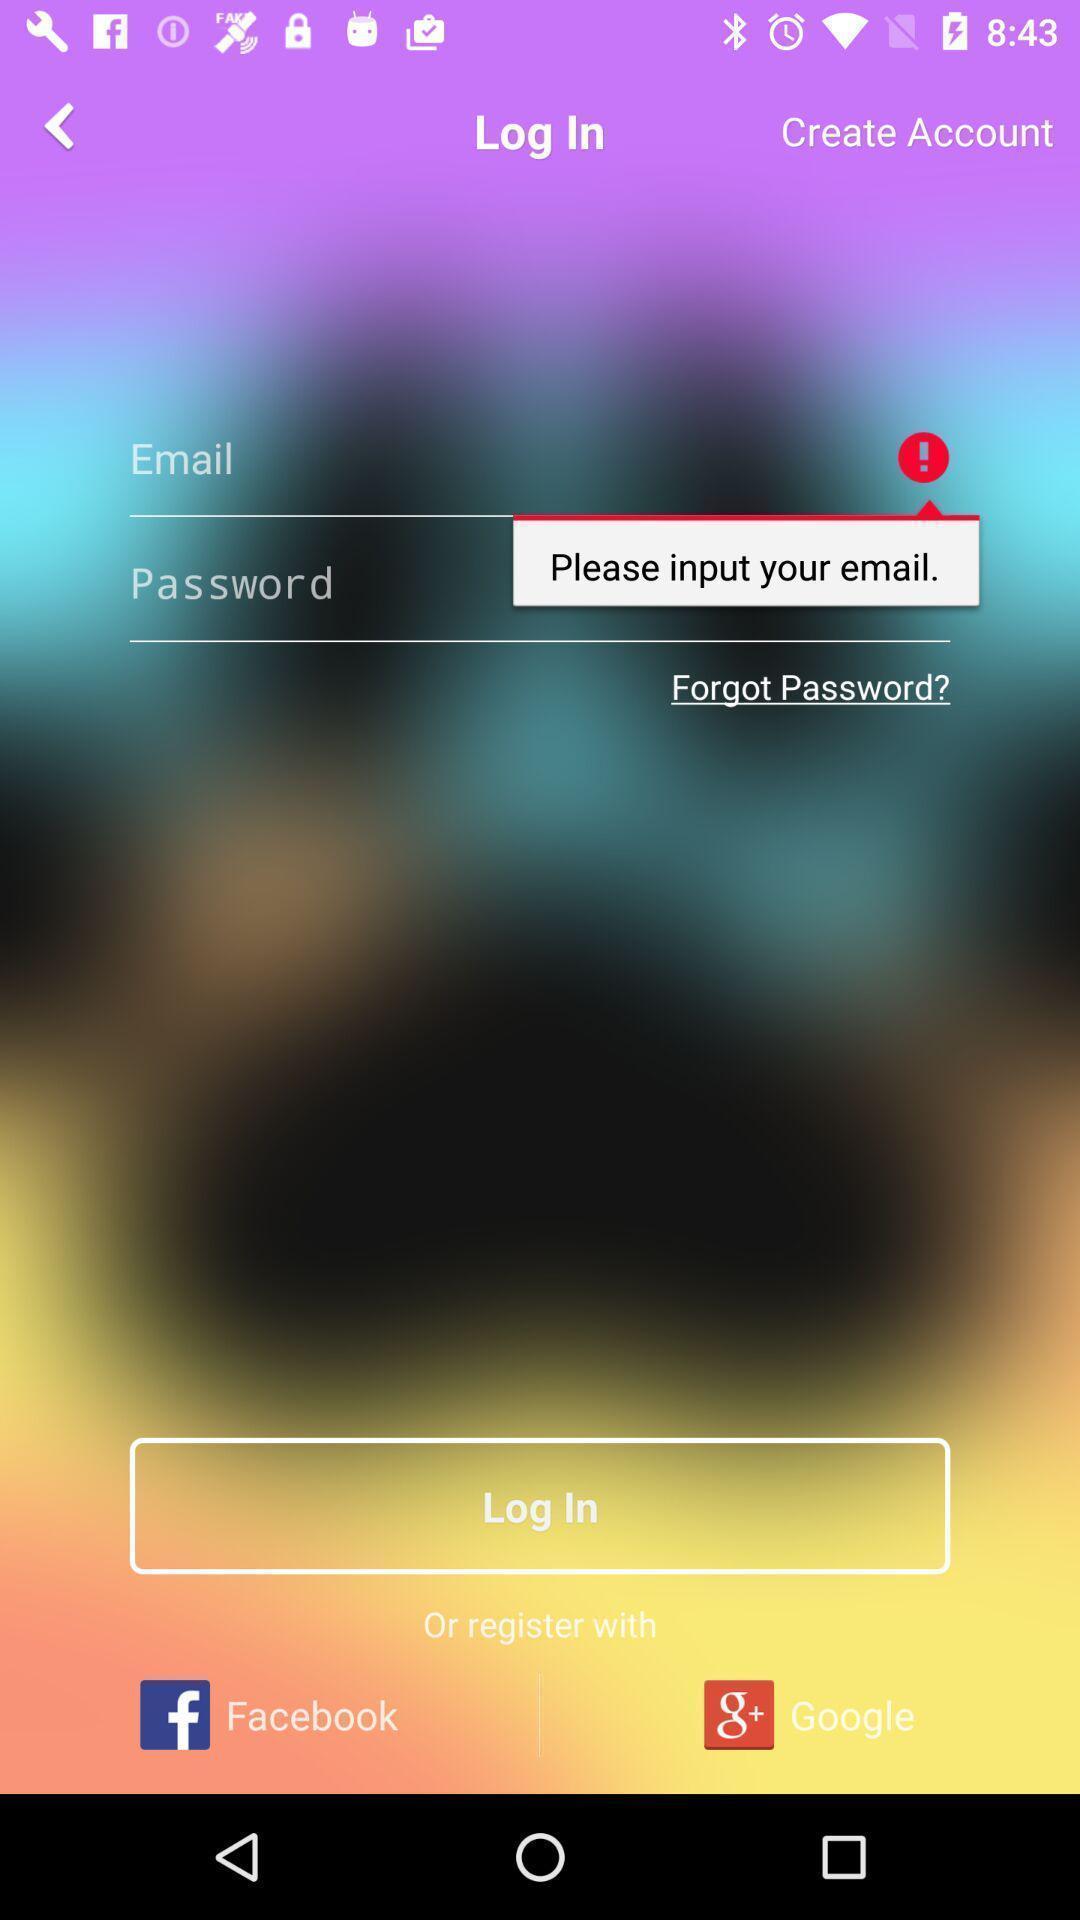Describe this image in words. Page displaying the options to enter login credentials. 